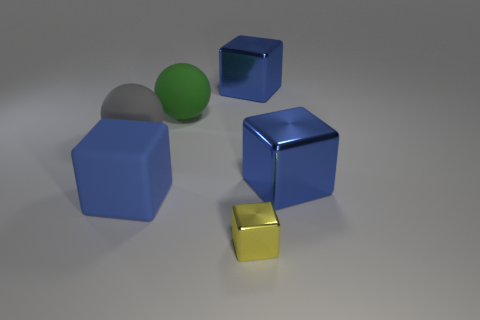Subtract all green balls. How many blue cubes are left? 3 Subtract 2 cubes. How many cubes are left? 2 Subtract all yellow blocks. How many blocks are left? 3 Subtract all yellow cubes. How many cubes are left? 3 Add 3 tiny yellow metallic cubes. How many objects exist? 9 Subtract all blocks. How many objects are left? 2 Add 4 large blue shiny blocks. How many large blue shiny blocks are left? 6 Add 2 big blue objects. How many big blue objects exist? 5 Subtract 1 green spheres. How many objects are left? 5 Subtract all gray blocks. Subtract all yellow cylinders. How many blocks are left? 4 